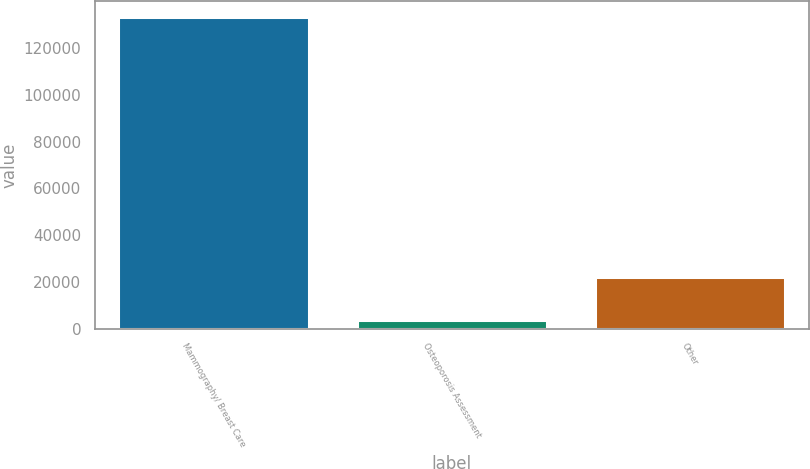Convert chart to OTSL. <chart><loc_0><loc_0><loc_500><loc_500><bar_chart><fcel>Mammography/ Breast Care<fcel>Osteoporosis Assessment<fcel>Other<nl><fcel>133304<fcel>3613<fcel>22120<nl></chart> 